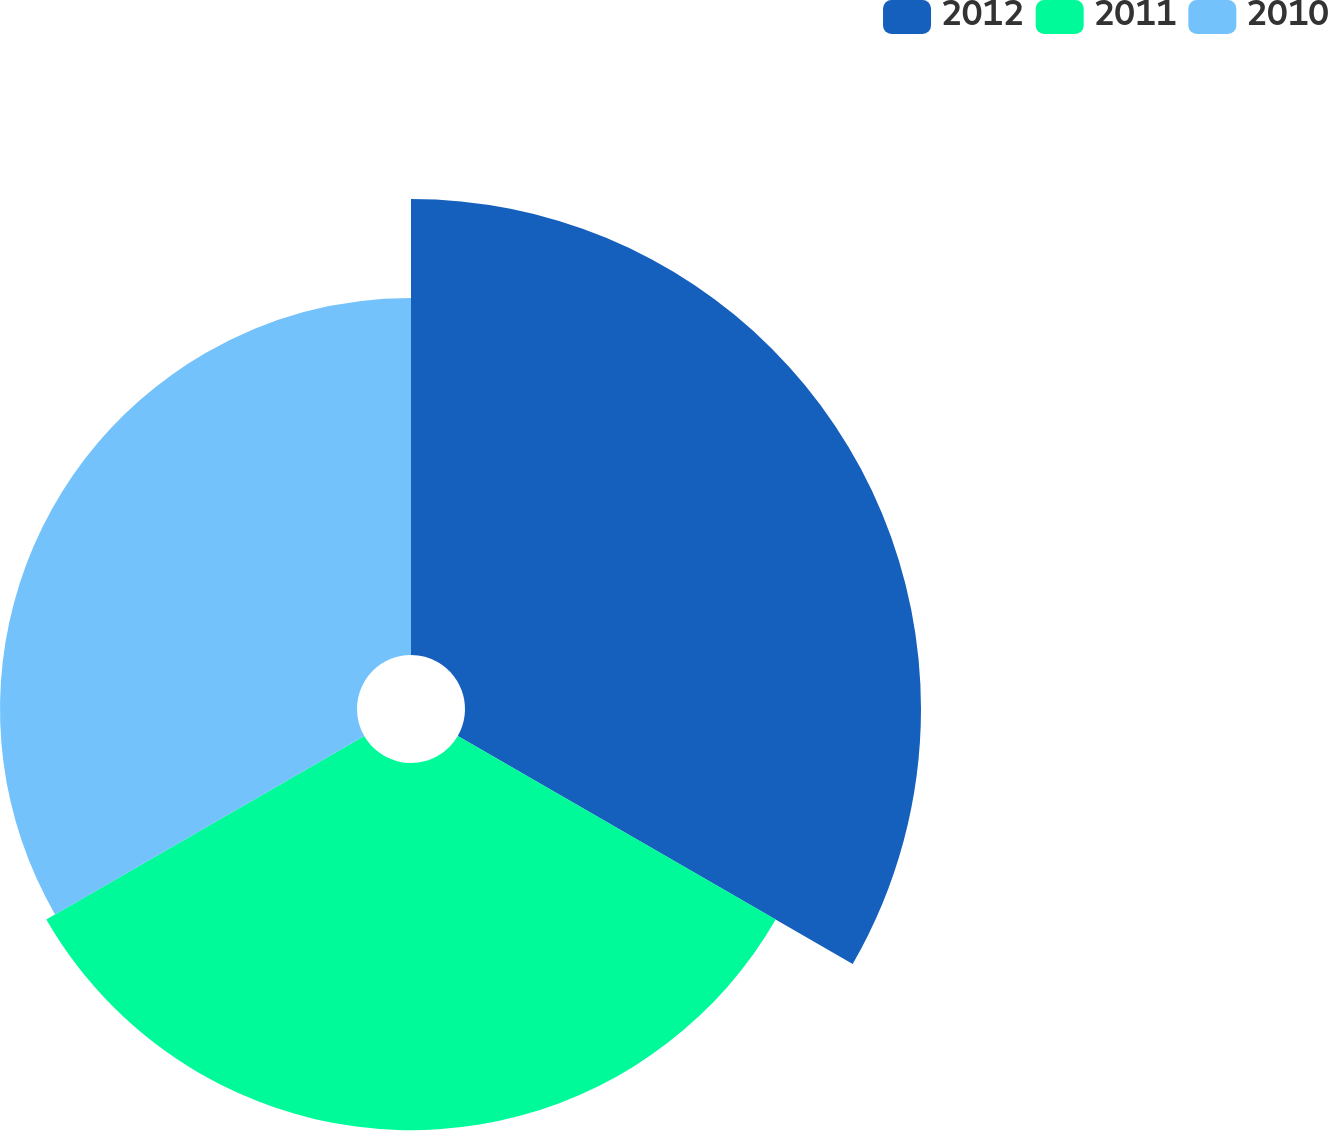Convert chart to OTSL. <chart><loc_0><loc_0><loc_500><loc_500><pie_chart><fcel>2012<fcel>2011<fcel>2010<nl><fcel>38.64%<fcel>31.11%<fcel>30.25%<nl></chart> 